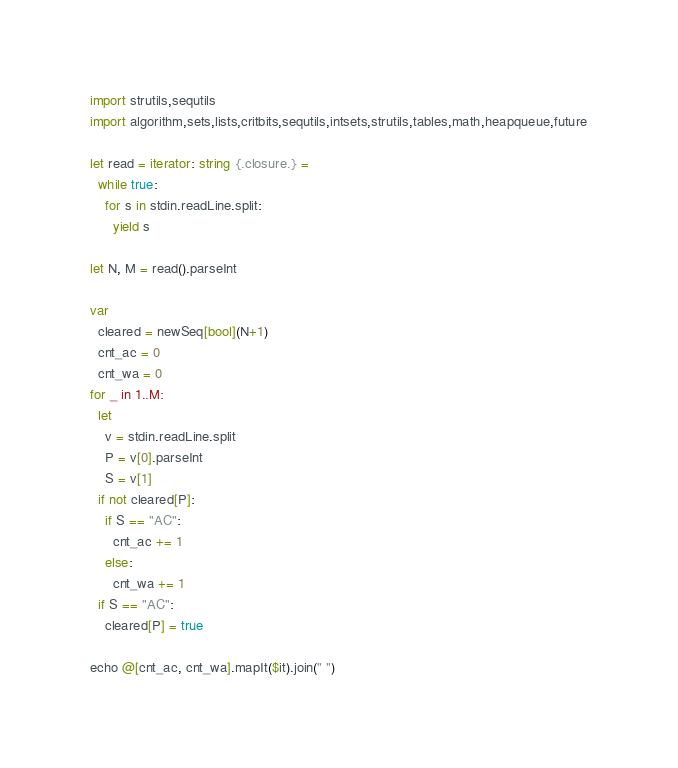Convert code to text. <code><loc_0><loc_0><loc_500><loc_500><_Nim_>import strutils,sequtils
import algorithm,sets,lists,critbits,sequtils,intsets,strutils,tables,math,heapqueue,future

let read = iterator: string {.closure.} =
  while true:
    for s in stdin.readLine.split:
      yield s

let N, M = read().parseInt

var
  cleared = newSeq[bool](N+1)
  cnt_ac = 0
  cnt_wa = 0
for _ in 1..M:
  let
    v = stdin.readLine.split
    P = v[0].parseInt
    S = v[1]
  if not cleared[P]:
    if S == "AC":
      cnt_ac += 1
    else:
      cnt_wa += 1
  if S == "AC":
    cleared[P] = true

echo @[cnt_ac, cnt_wa].mapIt($it).join(" ")
</code> 